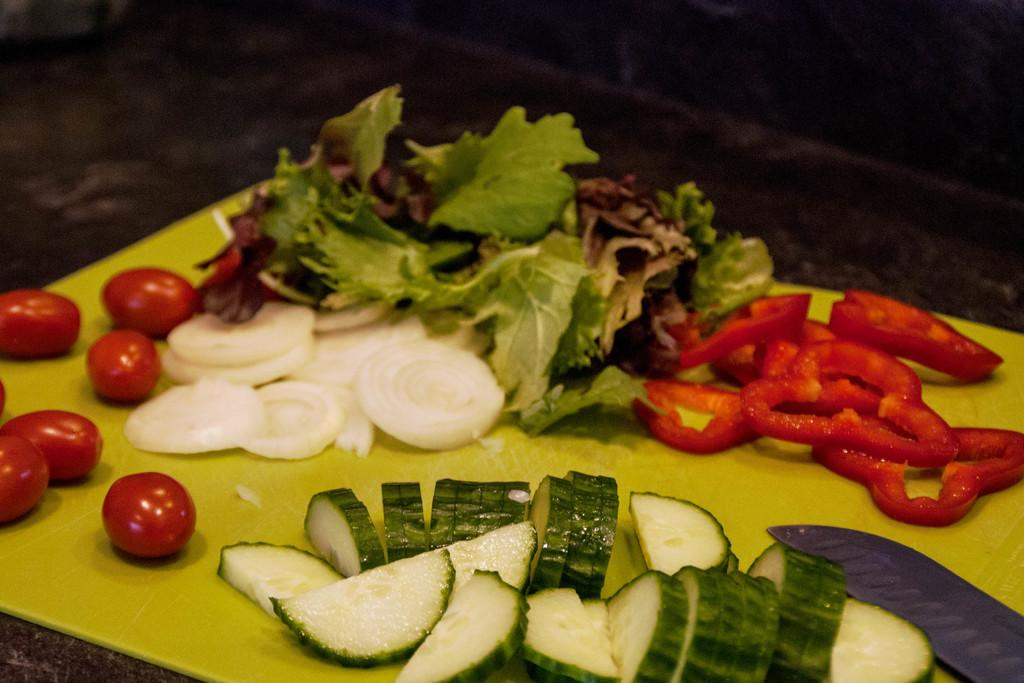What type of plant material can be seen in the image? There are green leaves in the image. What else can be seen in the image besides the green leaves? There are other vegetables in the image. How are the vegetables presented in the image? The vegetables are cut into pieces. What tool is used to cut the vegetables in the image? A knife is used to cut the vegetables. On what surface are the vegetables placed in the image? The vegetables are placed on a green surface. What type of bear can be seen holding a pear in the image? There is no bear or pear present in the image. 